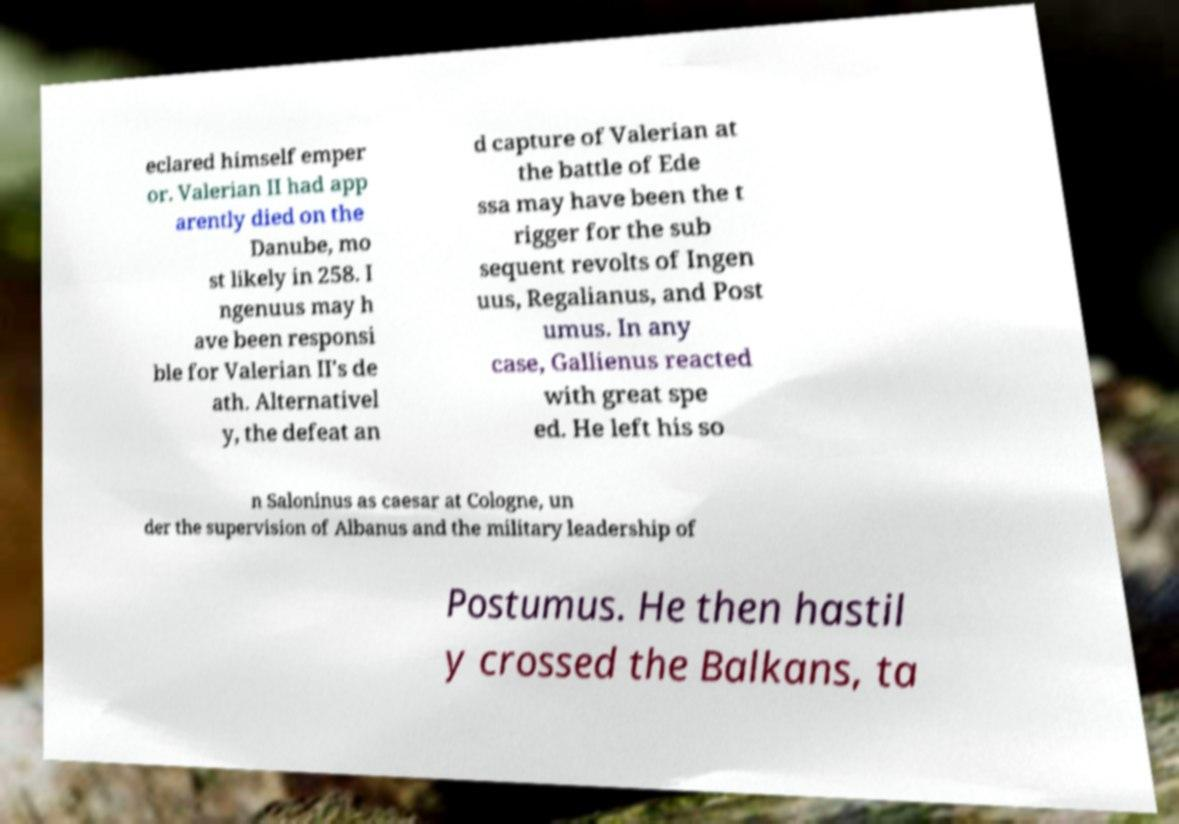I need the written content from this picture converted into text. Can you do that? eclared himself emper or. Valerian II had app arently died on the Danube, mo st likely in 258. I ngenuus may h ave been responsi ble for Valerian II's de ath. Alternativel y, the defeat an d capture of Valerian at the battle of Ede ssa may have been the t rigger for the sub sequent revolts of Ingen uus, Regalianus, and Post umus. In any case, Gallienus reacted with great spe ed. He left his so n Saloninus as caesar at Cologne, un der the supervision of Albanus and the military leadership of Postumus. He then hastil y crossed the Balkans, ta 